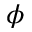Convert formula to latex. <formula><loc_0><loc_0><loc_500><loc_500>\phi</formula> 